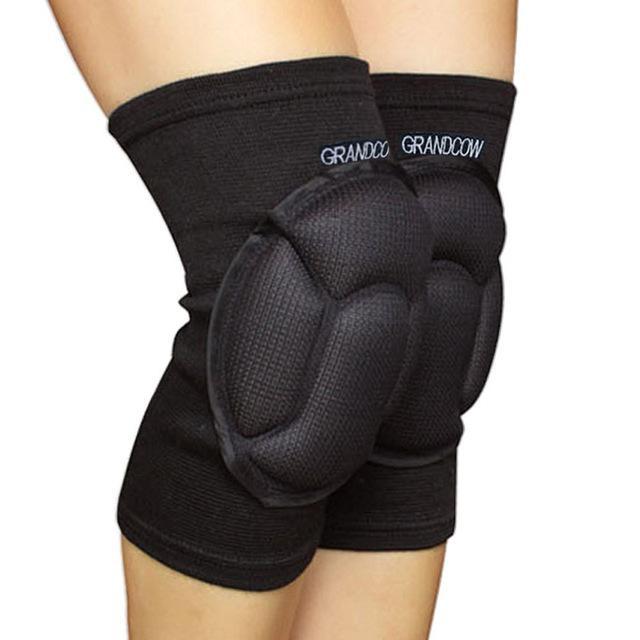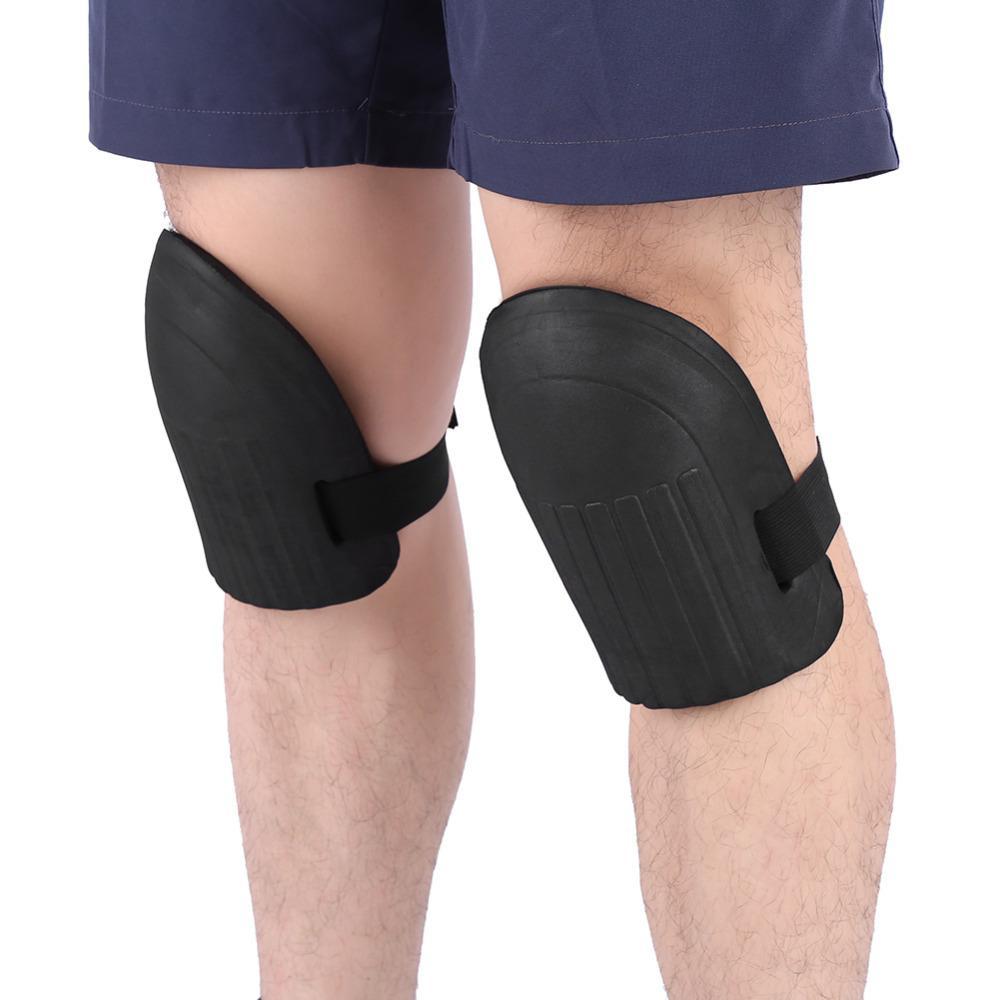The first image is the image on the left, the second image is the image on the right. Considering the images on both sides, is "The left and right image contains a total of two knee braces." valid? Answer yes or no. No. The first image is the image on the left, the second image is the image on the right. Given the left and right images, does the statement "Each image shows a pair of legs, with just one leg wearing a black knee wrap." hold true? Answer yes or no. No. 